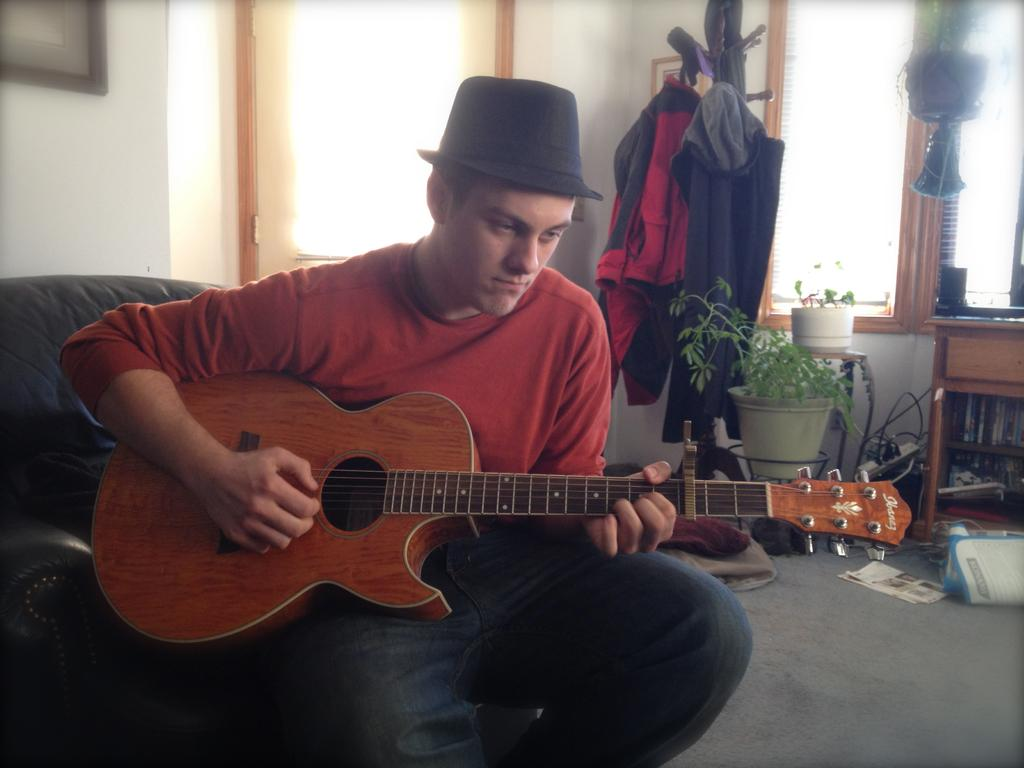What is the man in the image doing? The man is playing a guitar in the image. What type of furniture is present in the image? There is a sofa in the image. What kind of vegetation can be seen in the image? There is a plant in the image. What part of the room is visible in the image? The floor is visible in the image. What can be seen in the background of the image? There is a wall and a frame in the background of the image. Where is the lunchroom located in the image? There is no lunchroom present in the image. What type of light can be seen illuminating the cemetery in the image? There is no cemetery or light present in the image. 